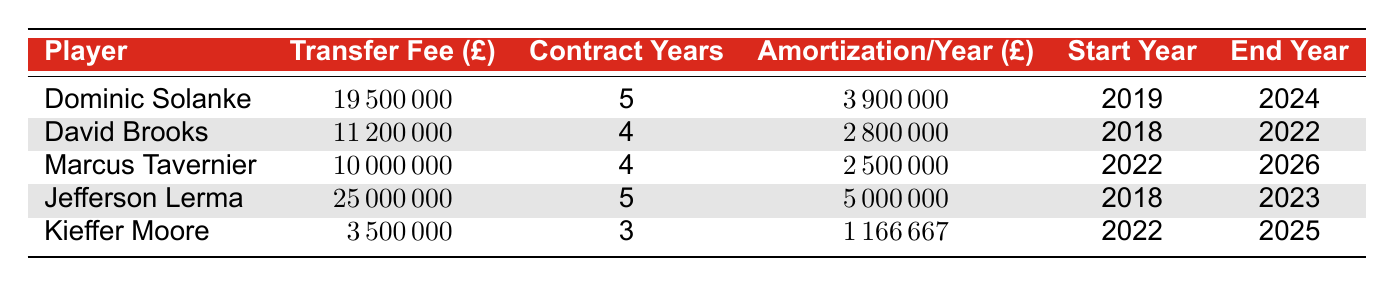What is the total transfer fee for Dominic Solanke? The transfer fee for Dominic Solanke is listed in the table as £19,500,000.
Answer: 19500000 How many years is David Brooks’ contract? The table indicates that David Brooks has a contract duration of 4 years.
Answer: 4 Is the amortization per year for Kieffer Moore greater than £1,000,000? The table shows Kieffer Moore's amortization per year as £1,166,667, which is indeed greater than £1,000,000.
Answer: Yes What is the average amortization per year of the players listed? The amortization per year values are £3,900,000, £2,800,000, £2,500,000, £5,000,000, and £1,166,667. Summing these gives £15,366,667, which divided by 5 players equals an average of approximately £3,073,333.
Answer: 3073333 Which player has the highest amortization per year? By comparing the amortization per year values, Jefferson Lerma has the highest at £5,000,000.
Answer: Jefferson Lerma What is the total transfer fee for players with contracts ending in 2022? The players with contracts ending in 2022 are David Brooks (£11,200,000) and Jefferson Lerma (£25,000,000). Adding these gives £36,200,000.
Answer: 36200000 How many players have contracts that end after 2024? The players whose contracts end after 2024 are Marcus Tavernier and Kieffer Moore, a total of 2 players.
Answer: 2 What is the difference in transfer fees between Dominic Solanke and Marcus Tavernier? Dominic Solanke's transfer fee is £19,500,000, and Marcus Tavernier's is £10,000,000. The difference is £19,500,000 - £10,000,000 = £9,500,000.
Answer: 9500000 